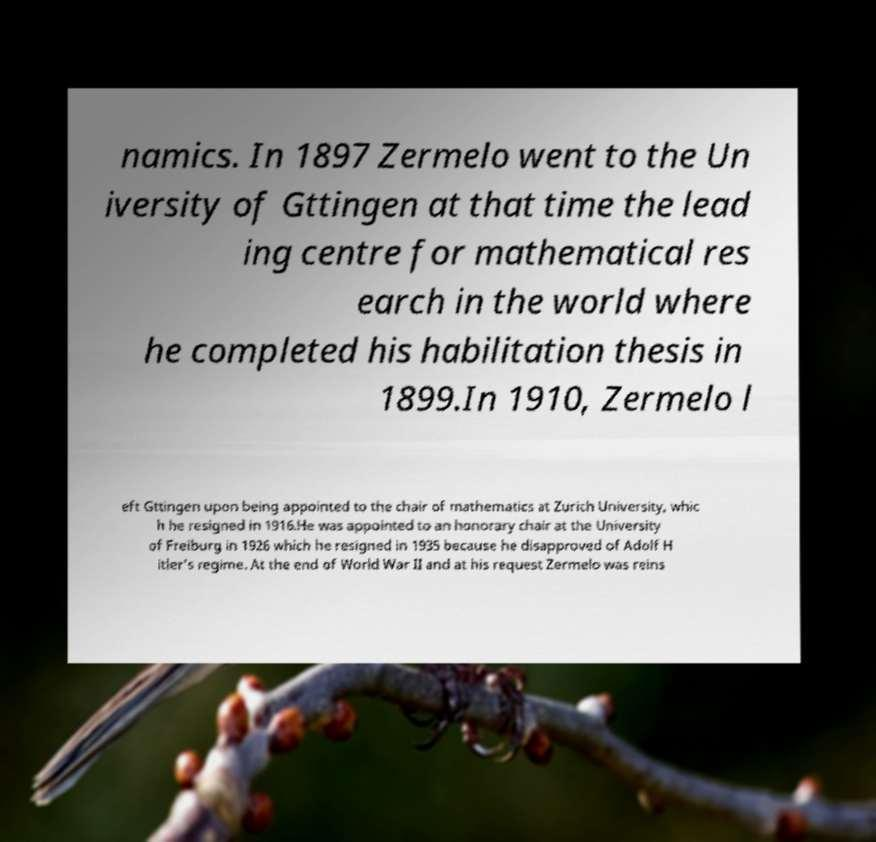Please identify and transcribe the text found in this image. namics. In 1897 Zermelo went to the Un iversity of Gttingen at that time the lead ing centre for mathematical res earch in the world where he completed his habilitation thesis in 1899.In 1910, Zermelo l eft Gttingen upon being appointed to the chair of mathematics at Zurich University, whic h he resigned in 1916.He was appointed to an honorary chair at the University of Freiburg in 1926 which he resigned in 1935 because he disapproved of Adolf H itler's regime. At the end of World War II and at his request Zermelo was reins 